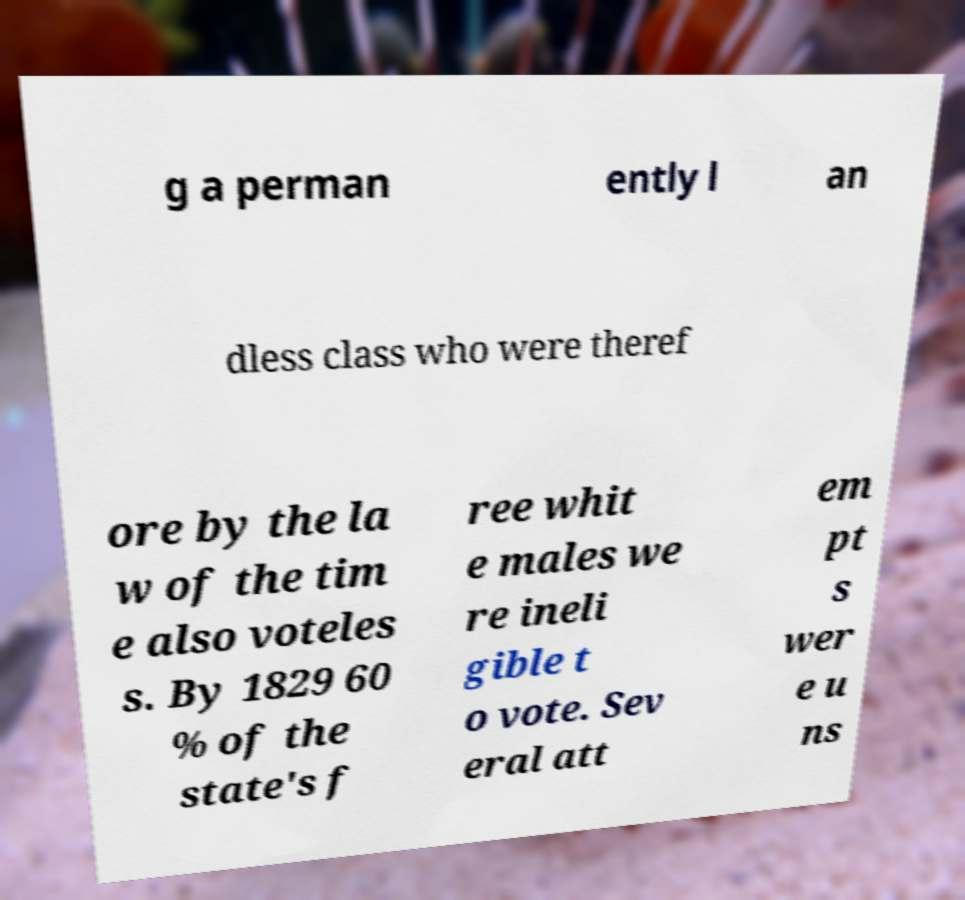For documentation purposes, I need the text within this image transcribed. Could you provide that? g a perman ently l an dless class who were theref ore by the la w of the tim e also voteles s. By 1829 60 % of the state's f ree whit e males we re ineli gible t o vote. Sev eral att em pt s wer e u ns 